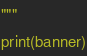<code> <loc_0><loc_0><loc_500><loc_500><_Python_>"""
print(banner)
</code> 